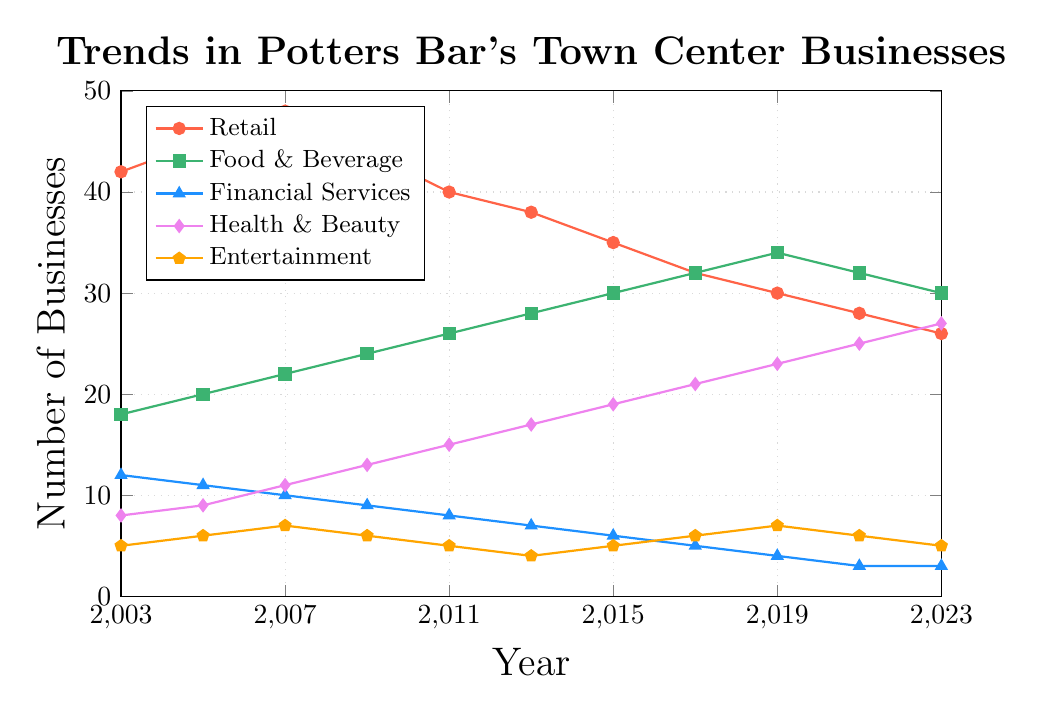How has the number of Retail businesses changed from 2003 to 2023? In 2003, there were 42 Retail businesses. By 2023, the number had decreased to 26. The change is 42 - 26.
Answer: The number of Retail businesses decreased by 16 Which industry had the highest number of businesses in 2023? In 2023, the Health & Beauty industry had 27 businesses, the highest among all the industries shown on the chart.
Answer: Health & Beauty What is the total number of Food & Beverage businesses and Financial Services businesses in 2013? In 2013, the number of Food & Beverage businesses was 28, and the number of Financial Services businesses was 7. Summing them up, 28 + 7 = 35.
Answer: 35 Between 2009 and 2011, which industry saw the largest percentage increase in the number of businesses? The Food & Beverage industry increased from 24 to 26 (an increase of 2), Financial Services decreased by 1, Health & Beauty increased from 13 to 15 (an increase of 2), and Entertainment decreased by 1. The percentage increase for Food & Beverage is 2/24 = 8.33%, and for Health & Beauty, it's 2/13 = 15.38%. Health & Beauty saw the largest percentage increase.
Answer: Health & Beauty Compare the trends of Retail and Health & Beauty businesses between 2003 and 2023. In 2003, Retail had 42 businesses and Health & Beauty had 8. By 2023, Retail had decreased to 26 while Health & Beauty increased to 27. Retail shows a declining trend, whereas Health & Beauty shows a rising trend.
Answer: Retail decreased, Health & Beauty increased Which industry had the least variation in the number of businesses over the two decades? Financial Services had a steady decline from 12 in 2003 to 3 in 2023, with small yearly changes compared to other industries.
Answer: Financial Services Which year saw the highest number of total businesses across all industries? We calculate the sum of businesses for each year and find that 2007 had the highest total: (48 + 22 + 10 + 11 + 7) = 98.
Answer: 2007 What is the trend in the number of Entertainment businesses between 2003 and 2023? The number of Entertainment businesses fluctuated slightly but had a net decrease from 5 businesses in 2003 to 5 businesses in 2023, indicating a relatively stable trend with some fluctuations.
Answer: Relatively stable What was the difference in the number of Health & Beauty and Retail businesses in 2019? In 2019, Health & Beauty had 23 businesses and Retail had 30. The difference is 30 - 23 = 7.
Answer: 7 